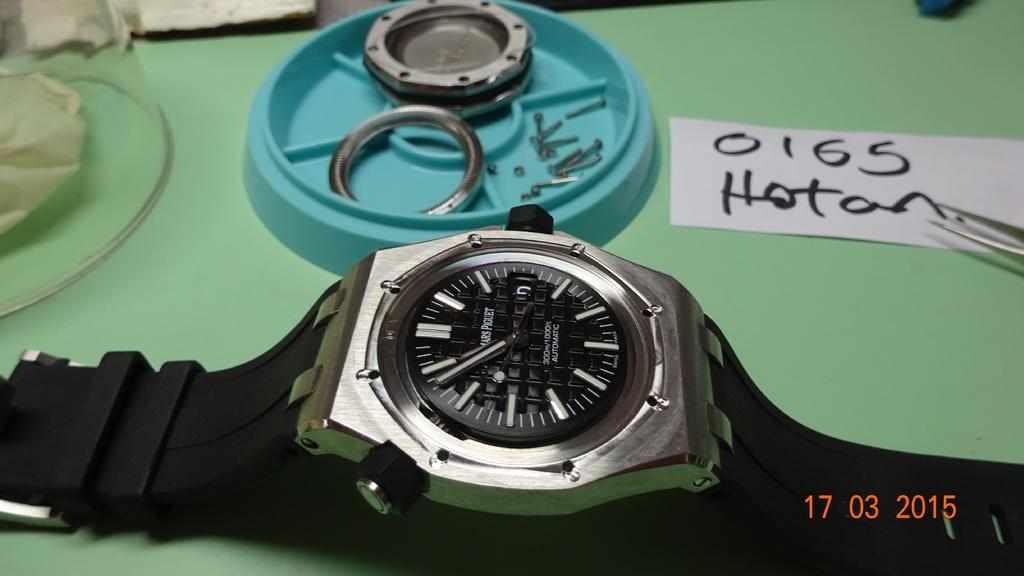Provide a one-sentence caption for the provided image. A watch is on the table and behind it is a piece of paper with the numbers 0165 written on it. 